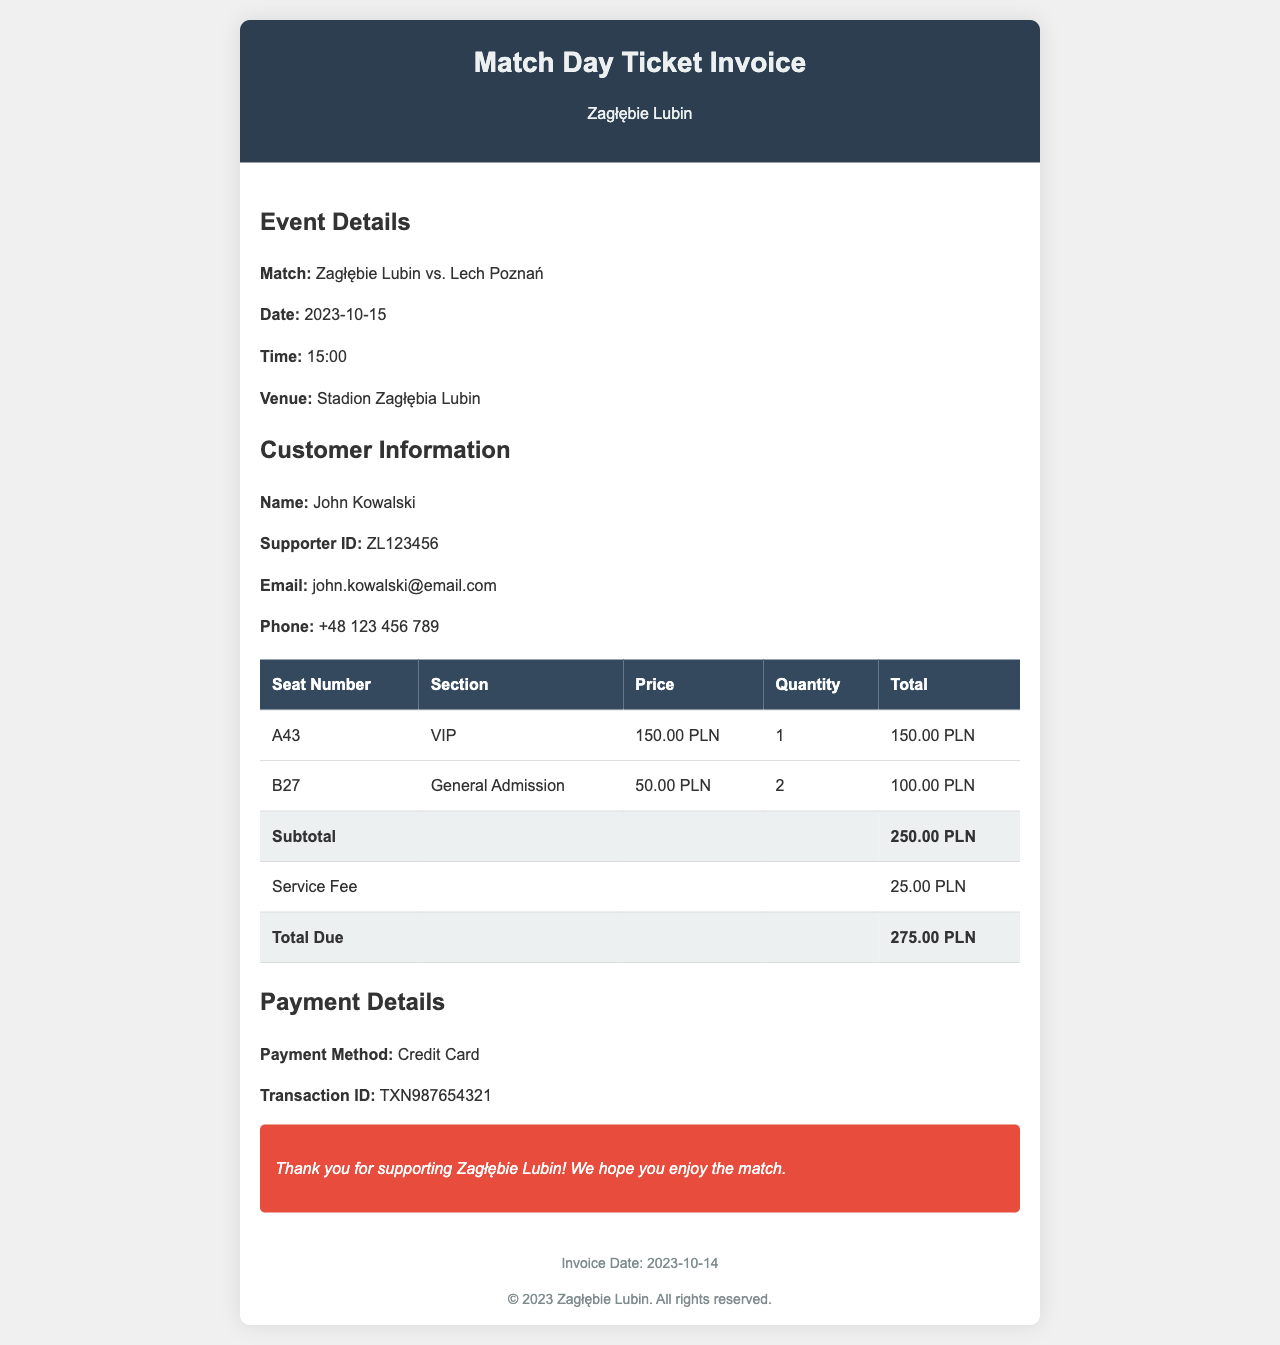what is the match date? The match date is specified in the document under event details.
Answer: 2023-10-15 who is the customer? The customer information section provides the name.
Answer: John Kowalski what is the seat number for the VIP section? The document lists seat details, including the VIP section.
Answer: A43 what is the subtotal amount? The subtotal amount is calculated from the seat prices listed in the invoice.
Answer: 250.00 PLN how much is the service fee? The service fee is explicitly stated in the total cost breakdown table.
Answer: 25.00 PLN what is the total due amount? The total due amount is summarized at the bottom of the invoice.
Answer: 275.00 PLN what payment method was used? The payment details provide information regarding the method.
Answer: Credit Card what is the transaction ID? The transaction ID is found in the payment details section.
Answer: TXN987654321 how many general admission tickets were purchased? The quantity for general admission is listed in the ticket details.
Answer: 2 